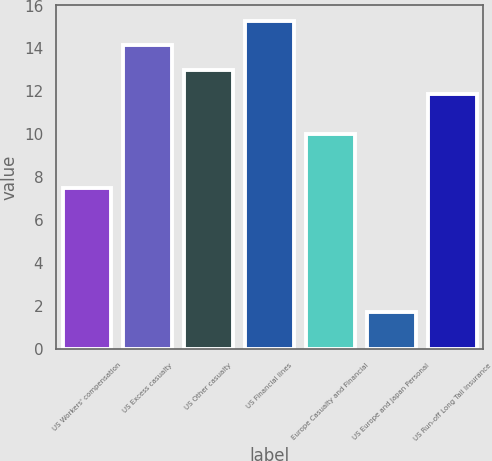Convert chart. <chart><loc_0><loc_0><loc_500><loc_500><bar_chart><fcel>US Workers' compensation<fcel>US Excess casualty<fcel>US Other casualty<fcel>US Financial lines<fcel>Europe Casualty and Financial<fcel>US Europe and Japan Personal<fcel>US Run-off Long Tail Insurance<nl><fcel>7.5<fcel>14.14<fcel>13.02<fcel>15.26<fcel>10<fcel>1.7<fcel>11.9<nl></chart> 